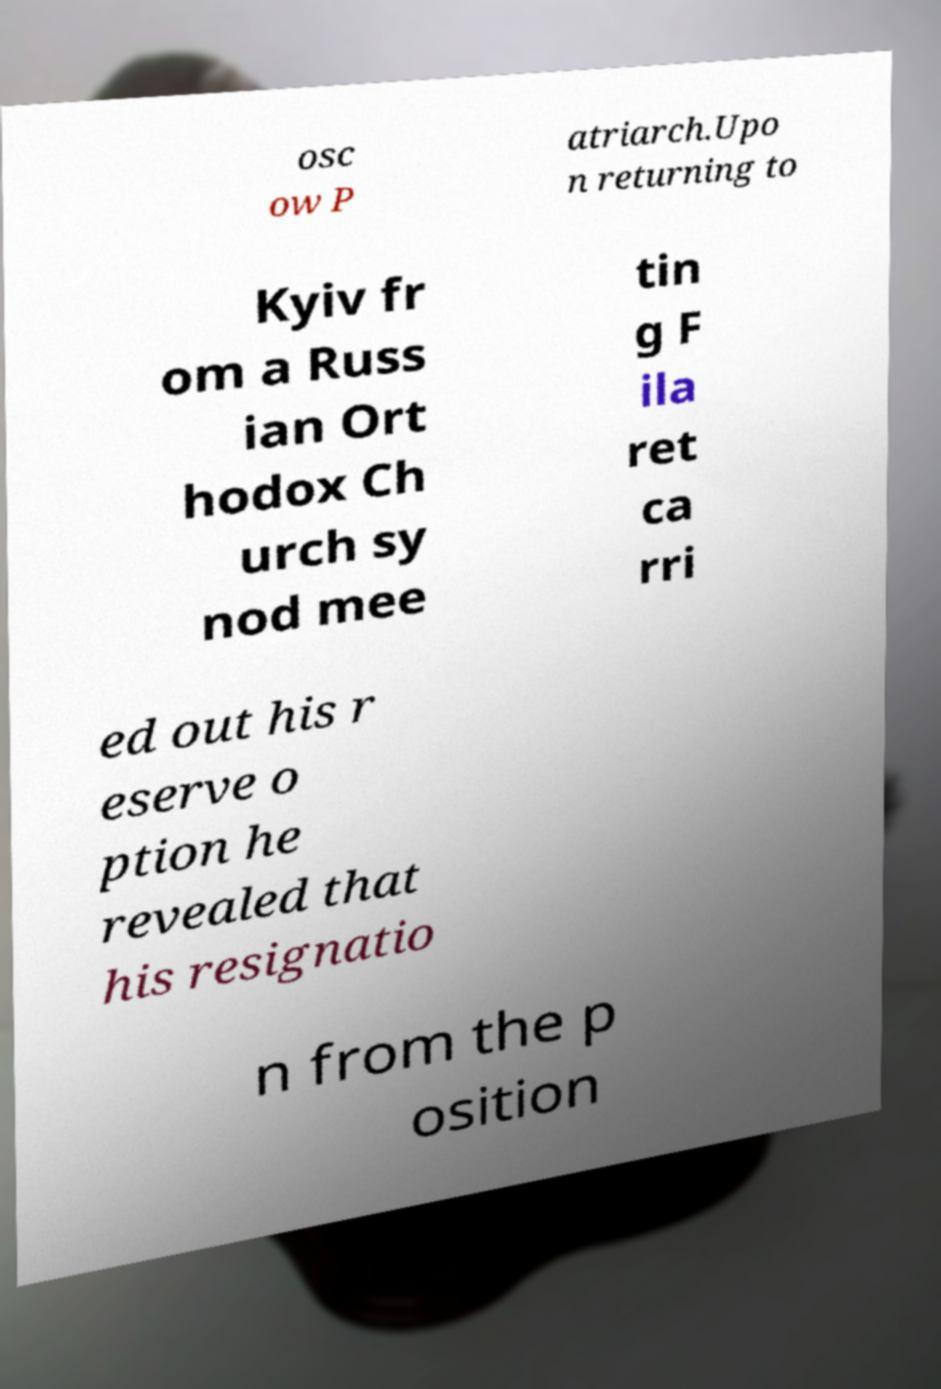What messages or text are displayed in this image? I need them in a readable, typed format. osc ow P atriarch.Upo n returning to Kyiv fr om a Russ ian Ort hodox Ch urch sy nod mee tin g F ila ret ca rri ed out his r eserve o ption he revealed that his resignatio n from the p osition 